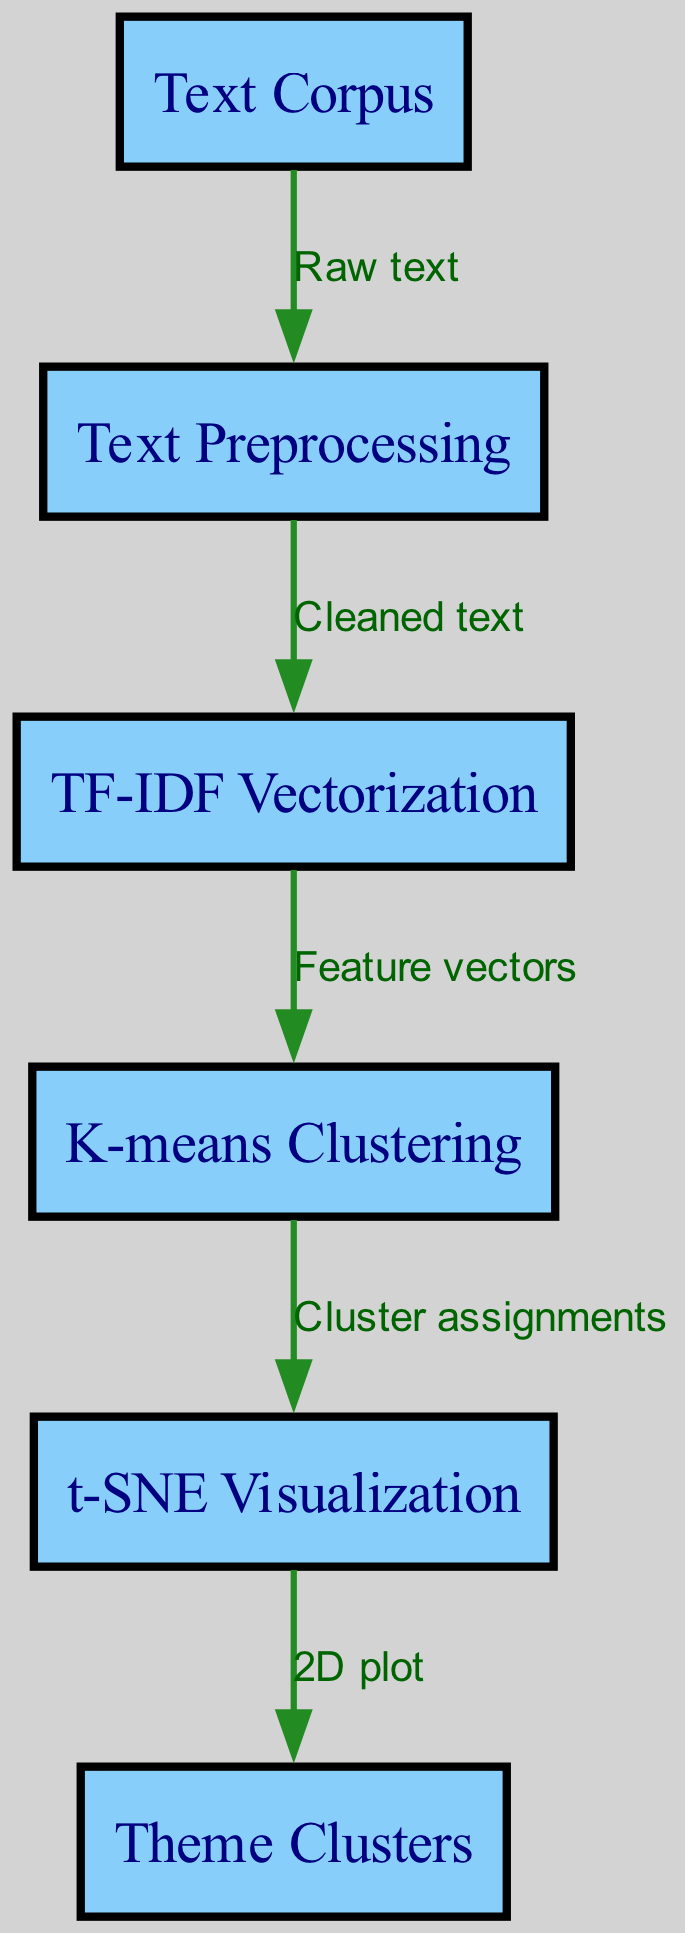What is the first node in the diagram? The first node in the diagram is labeled "Text Corpus," which indicates the starting point of the process.
Answer: Text Corpus How many nodes are present in the diagram? By counting the individual labeled boxes, there are six nodes: Text Corpus, Text Preprocessing, TF-IDF Vectorization, K-means Clustering, t-SNE Visualization, and Theme Clusters.
Answer: Six What label is associated with the edge from "cluster" to "visualize"? The edge from "cluster" to "visualize" is labeled "Cluster assignments," representing the output of the clustering step that feeds into the visualization step.
Answer: Cluster assignments Which node follows the "vectorize" node? The "cluster" node follows the "vectorize" node, indicating that clustering is performed after vectorization of the text data.
Answer: Cluster What is the output of the diagram? The final output of the diagram is labeled "Theme Clusters," representing the thematic groups determined from the clustering process.
Answer: Theme Clusters What step comes after "Text Preprocessing"? The step that comes after "Text Preprocessing" is "TF-IDF Vectorization," which involves converting the cleaned text into numerical feature vectors.
Answer: TF-IDF Vectorization How does the output relate to the input node? The output ("Theme Clusters") is the result of processing the input ("Text Corpus") through various steps, showing the relations and groups formed from the initial data.
Answer: Relation through processing steps What type of algorithm is utilized in the "cluster" node? The "K-means Clustering" algorithm is utilized in the "cluster" node, which is a popular method for partitioning data into distinct groups.
Answer: K-means Clustering What visual representation is created from the clustering results? The step "t-SNE Visualization" creates a visual representation, specifically a 2D plot, which helps to visualize how the clusters are arranged spatially.
Answer: 2D plot 